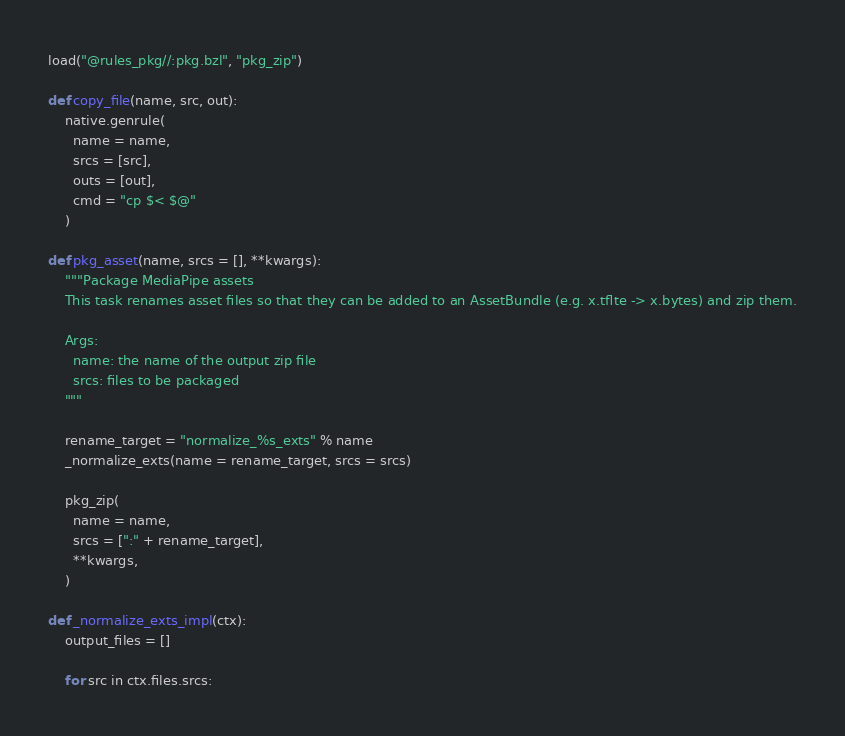Convert code to text. <code><loc_0><loc_0><loc_500><loc_500><_Python_>load("@rules_pkg//:pkg.bzl", "pkg_zip")

def copy_file(name, src, out):
    native.genrule(
      name = name,
      srcs = [src],
      outs = [out],
      cmd = "cp $< $@"
    )

def pkg_asset(name, srcs = [], **kwargs):
    """Package MediaPipe assets
    This task renames asset files so that they can be added to an AssetBundle (e.g. x.tflte -> x.bytes) and zip them.

    Args:
      name: the name of the output zip file
      srcs: files to be packaged
    """

    rename_target = "normalize_%s_exts" % name
    _normalize_exts(name = rename_target, srcs = srcs)

    pkg_zip(
      name = name,
      srcs = [":" + rename_target],
      **kwargs,
    )

def _normalize_exts_impl(ctx):
    output_files = []

    for src in ctx.files.srcs:</code> 